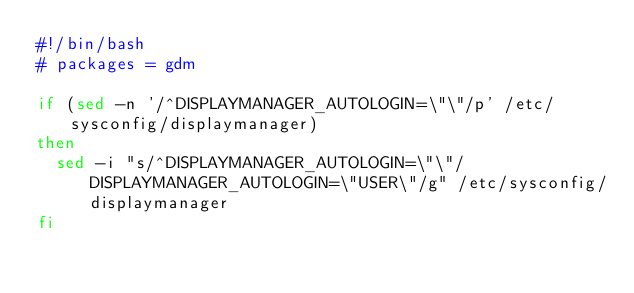<code> <loc_0><loc_0><loc_500><loc_500><_Bash_>#!/bin/bash
# packages = gdm

if (sed -n '/^DISPLAYMANAGER_AUTOLOGIN=\"\"/p' /etc/sysconfig/displaymanager)
then
  sed -i "s/^DISPLAYMANAGER_AUTOLOGIN=\"\"/DISPLAYMANAGER_AUTOLOGIN=\"USER\"/g" /etc/sysconfig/displaymanager
fi
</code> 